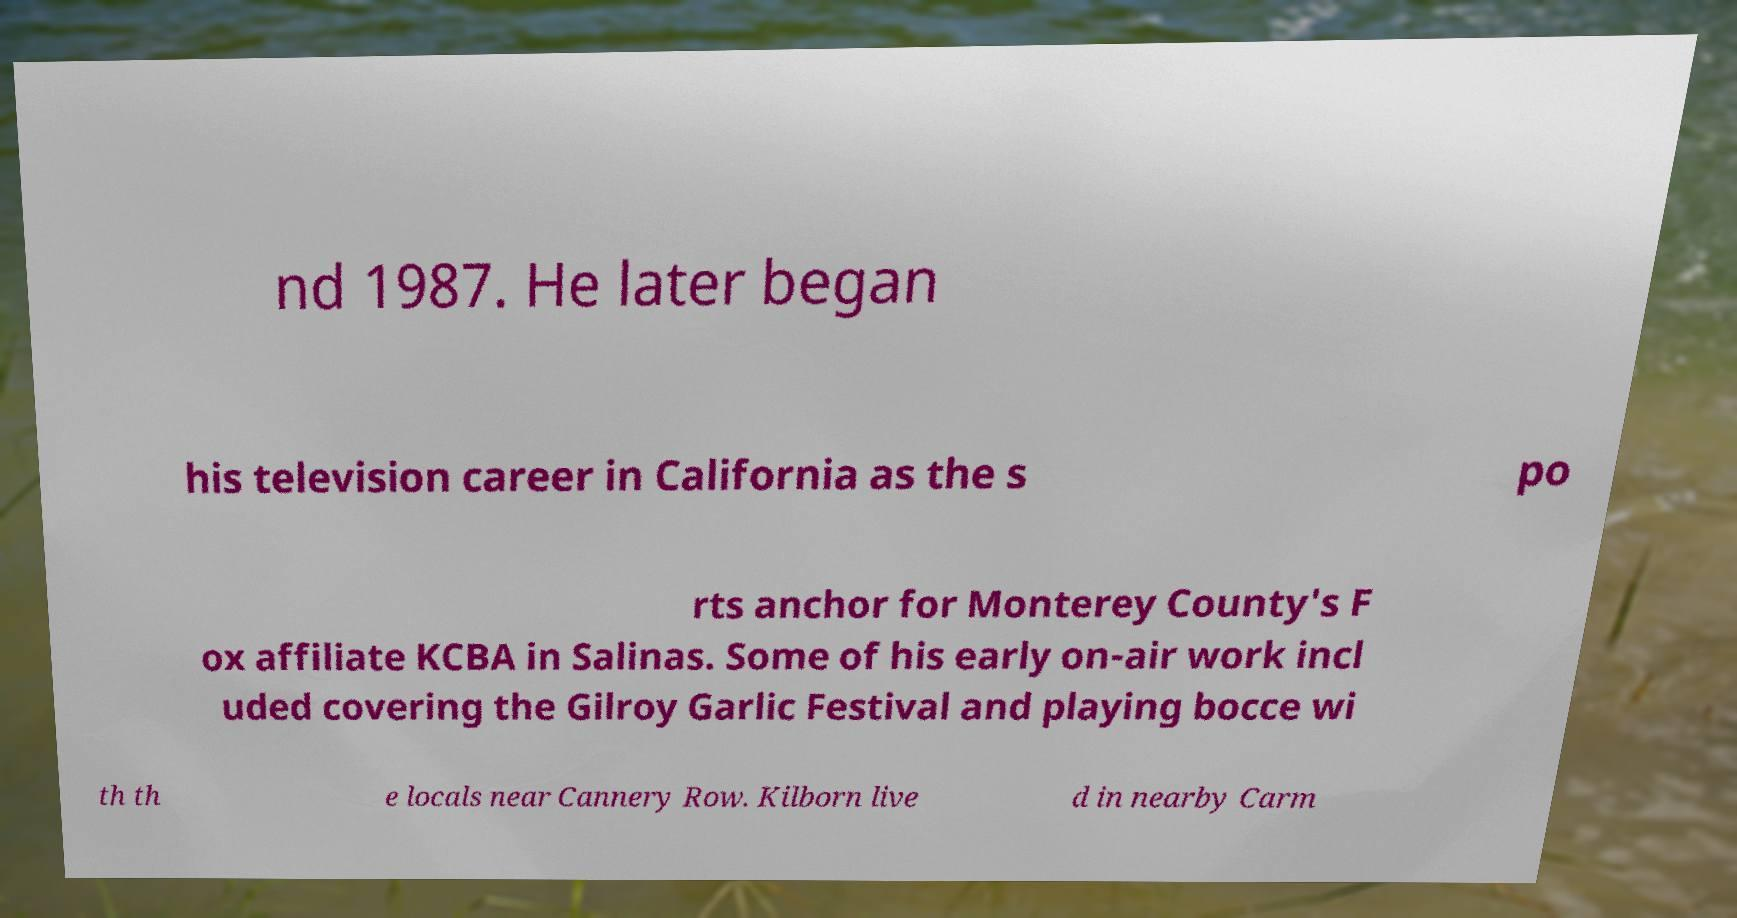Can you accurately transcribe the text from the provided image for me? nd 1987. He later began his television career in California as the s po rts anchor for Monterey County's F ox affiliate KCBA in Salinas. Some of his early on-air work incl uded covering the Gilroy Garlic Festival and playing bocce wi th th e locals near Cannery Row. Kilborn live d in nearby Carm 